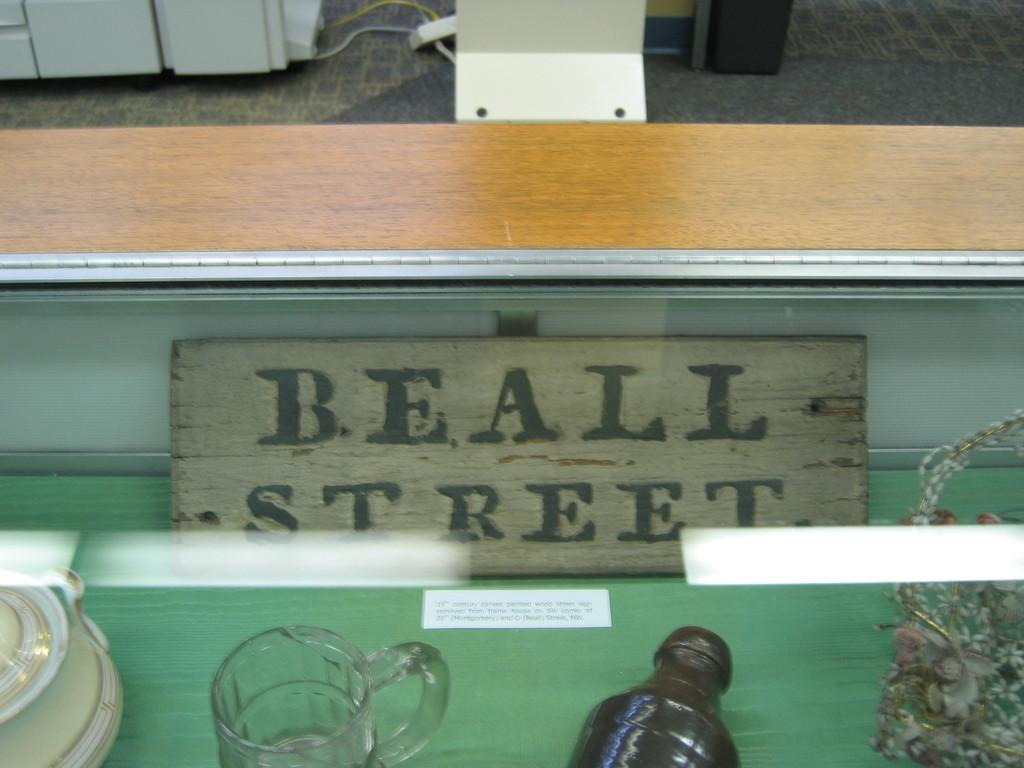<image>
Describe the image concisely. A Beall Street sign is laying behind some glasses and bottles. 